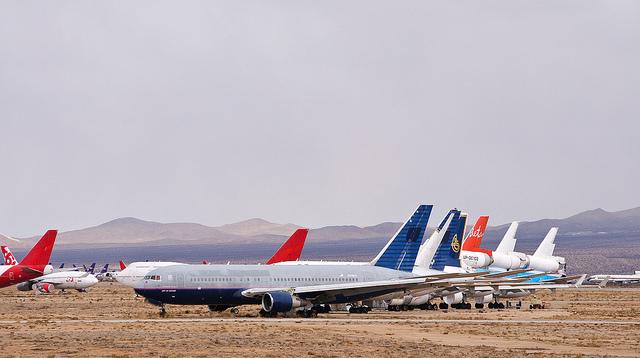Are there airplanes in this picture?
Short answer required. Yes. Are there mountains in the distance?
Quick response, please. Yes. Is there water in the background?
Keep it brief. No. 